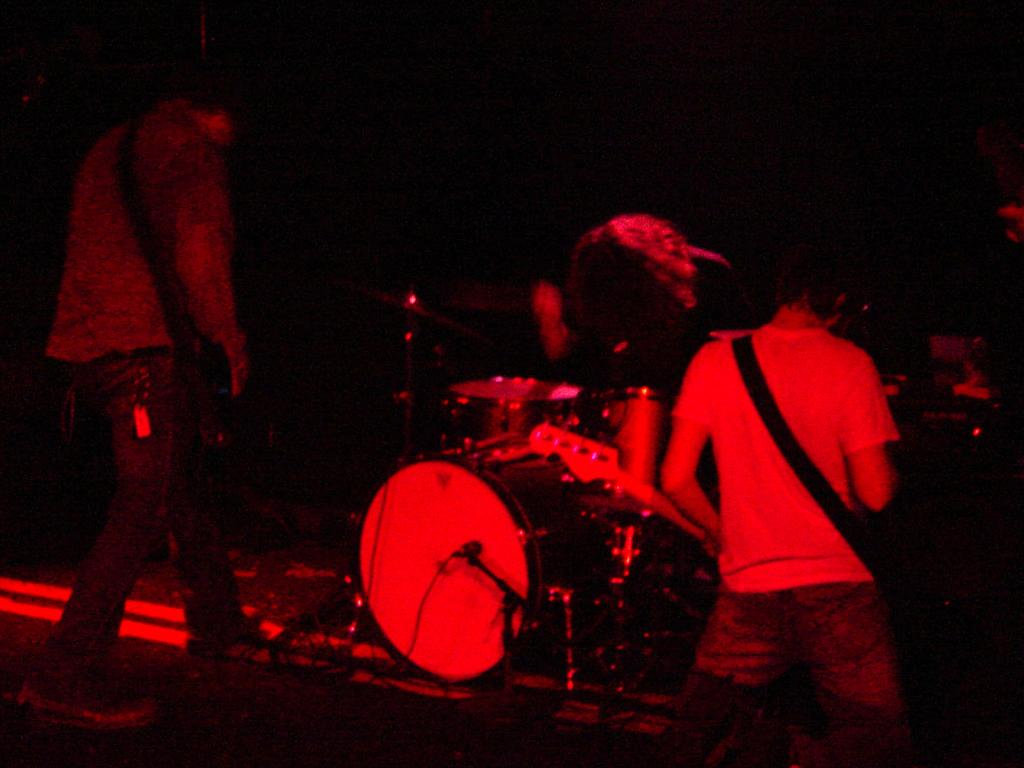What is happening in the image? There is a group of people in the image, and they are playing musical instruments. Where are the people playing their instruments? The people are on a stage. What type of skin condition can be seen on the people playing musical instruments in the image? There is no indication of any skin condition on the people playing musical instruments in the image. Are there any boats visible in the image? There are no boats present in the image. 